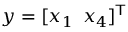<formula> <loc_0><loc_0><loc_500><loc_500>y = [ x _ { 1 } \, x _ { 4 } ] ^ { T }</formula> 